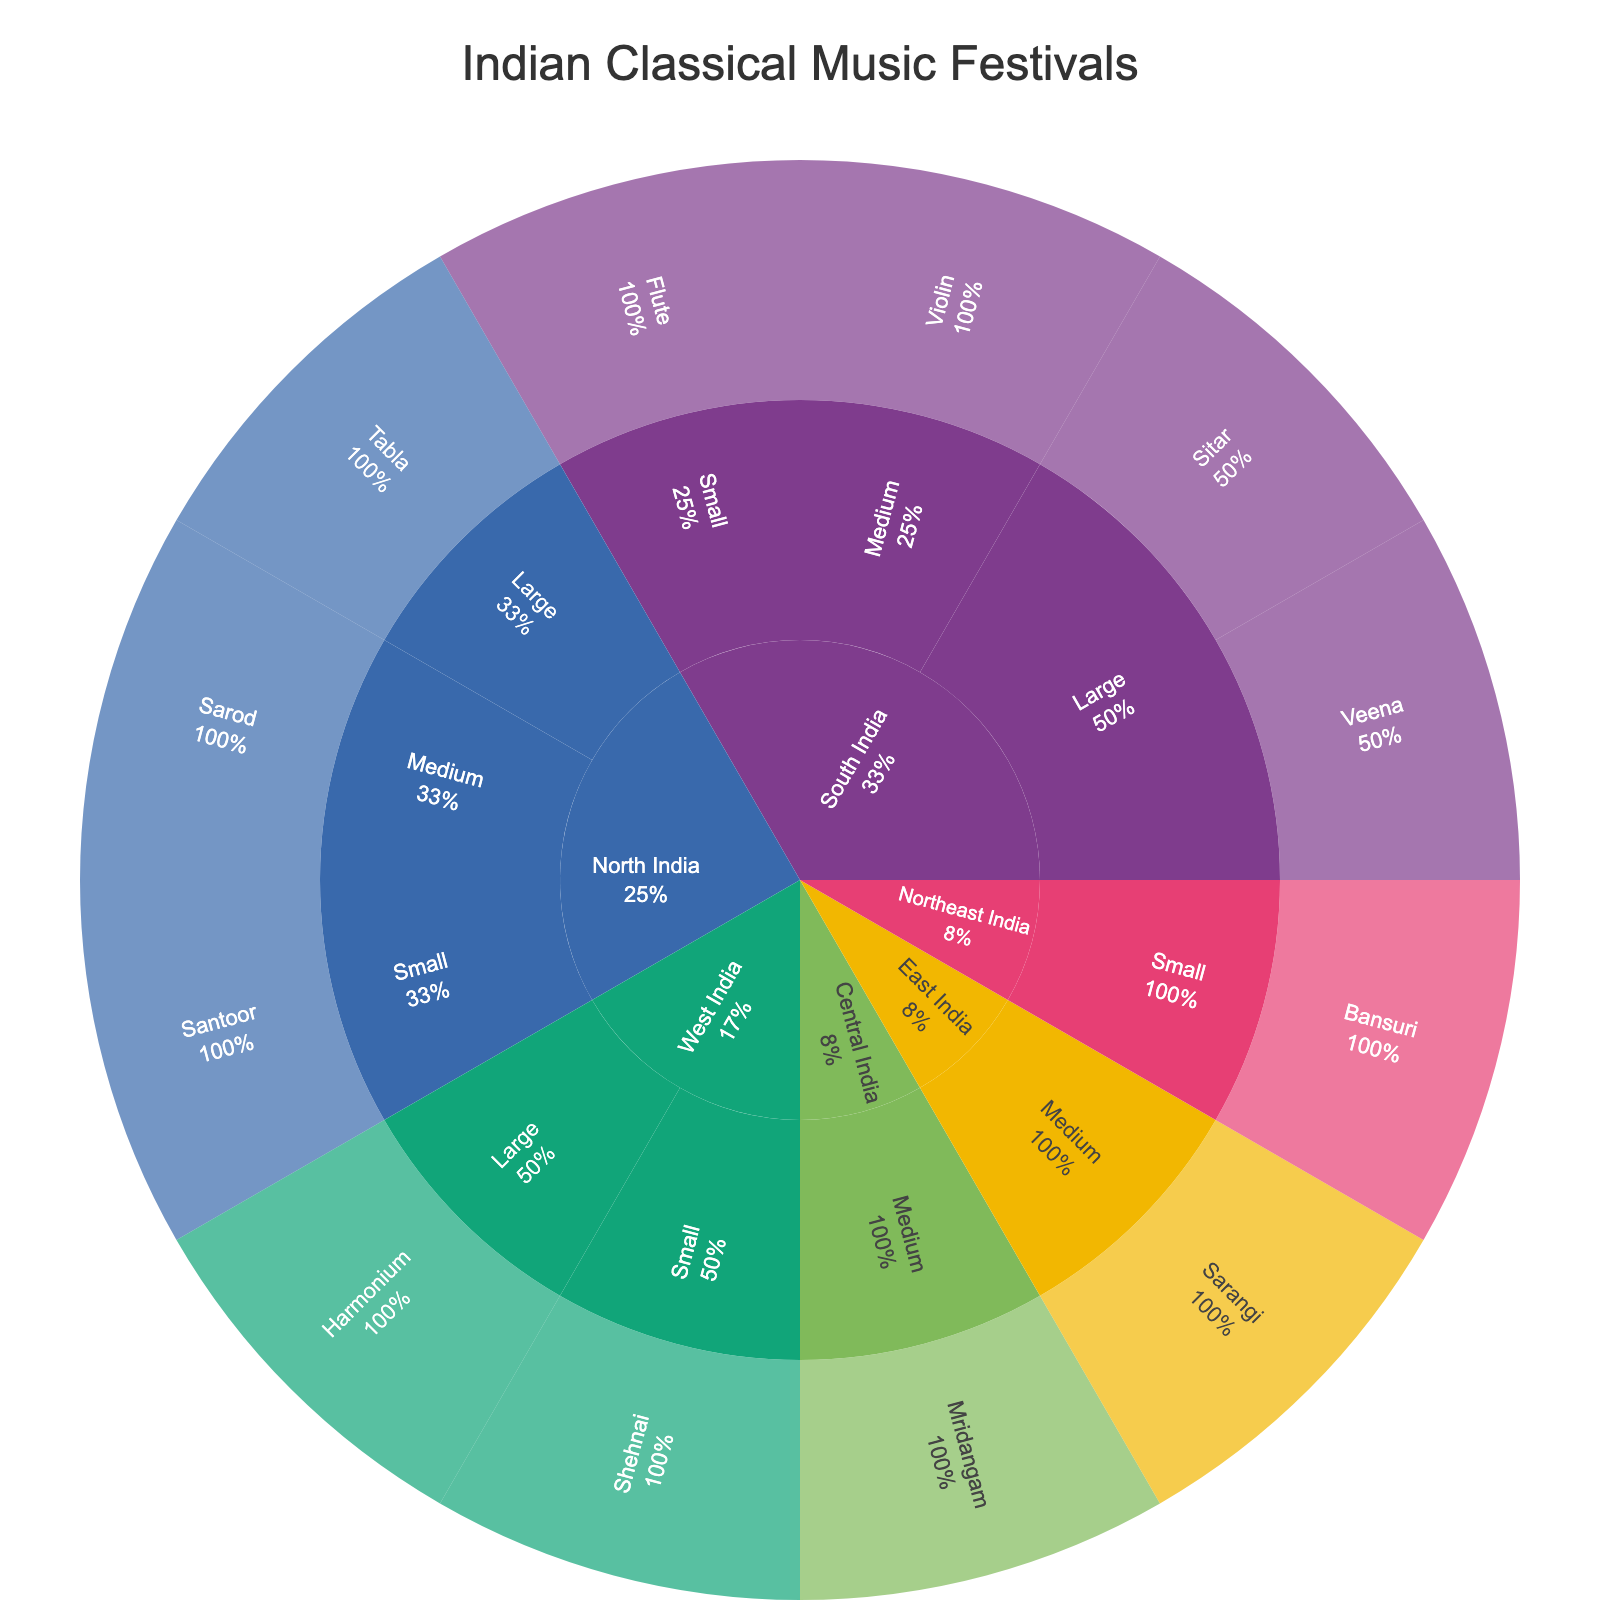What is the title of the figure? The title of the figure is usually mentioned at the top and summarizes the main theme of the plot.
Answer: Indian Classical Music Festivals Which featured instrument is associated with the Chennai Margazhi Festival? Hovering over or observing the segment for Chennai Margazhi Festival will show the featured instrument.
Answer: Veena How many festivals are categorized under South India? By counting the segments originating from "South India", you can determine the number of festivals categorized under it. There are 4 such festivals.
Answer: 4 Which locations have festivals categorized under the 'Large' size? Observing the segments under 'Large' size helps to see the respective locations they belong to. They include South India, North India, and West India.
Answer: South India, North India, West India Which festival features the Shehnai? By following the segments for Shehnai, you can identify the associated festival.
Answer: Gunidas Sangeet Sammelan Compare the number of medium-sized festivals in North India and East India. Which location has more? By counting the segments under the 'Medium' size category for North India and East India, you see that North India has 1 medium-sized festival while East India also has 1.
Answer: Both have 1 Which festival features the Tabla and in which location is it held? Following the segments for Tabla helps to see that the associated festival is the Dover Lane Music Conference and it's held in North India.
Answer: Dover Lane Music Conference, North India How many unique featured instruments are there in this figure? By counting the distinct featured instruments from each segment, the total number is found to be 12.
Answer: 12 Where is the Manipur Sangai Festival held? Observing the segments, the Manipur Sangai Festival is associated with the 'Northeast India' location.
Answer: Northeast India 